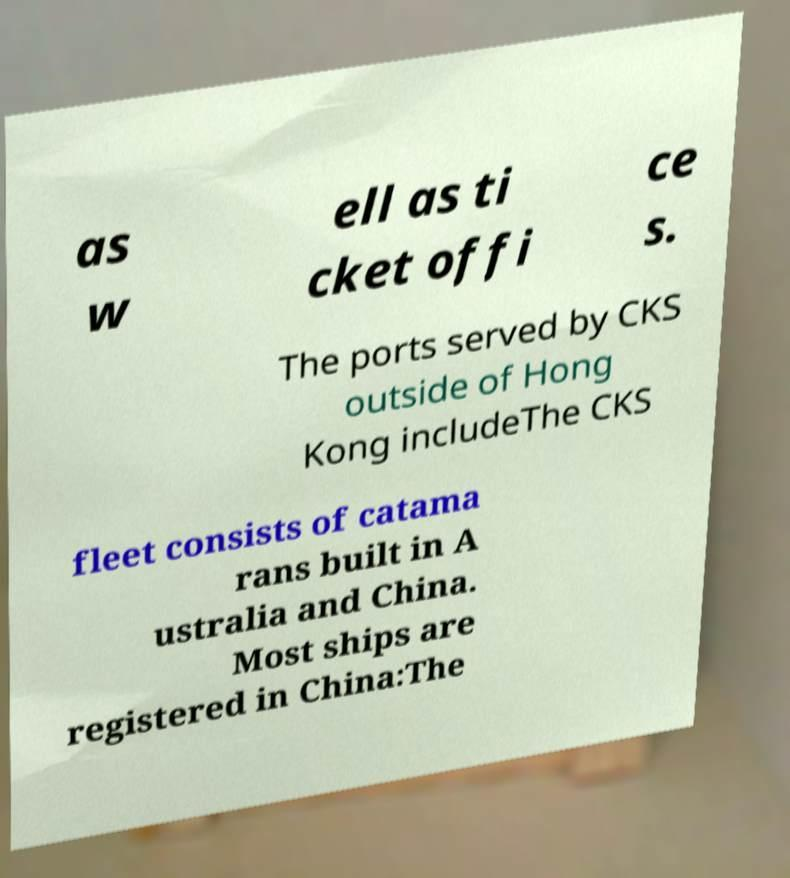Could you extract and type out the text from this image? as w ell as ti cket offi ce s. The ports served by CKS outside of Hong Kong includeThe CKS fleet consists of catama rans built in A ustralia and China. Most ships are registered in China:The 